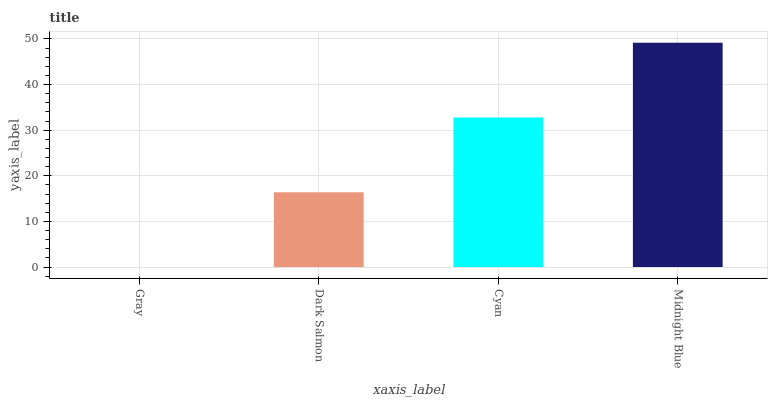Is Gray the minimum?
Answer yes or no. Yes. Is Midnight Blue the maximum?
Answer yes or no. Yes. Is Dark Salmon the minimum?
Answer yes or no. No. Is Dark Salmon the maximum?
Answer yes or no. No. Is Dark Salmon greater than Gray?
Answer yes or no. Yes. Is Gray less than Dark Salmon?
Answer yes or no. Yes. Is Gray greater than Dark Salmon?
Answer yes or no. No. Is Dark Salmon less than Gray?
Answer yes or no. No. Is Cyan the high median?
Answer yes or no. Yes. Is Dark Salmon the low median?
Answer yes or no. Yes. Is Dark Salmon the high median?
Answer yes or no. No. Is Cyan the low median?
Answer yes or no. No. 